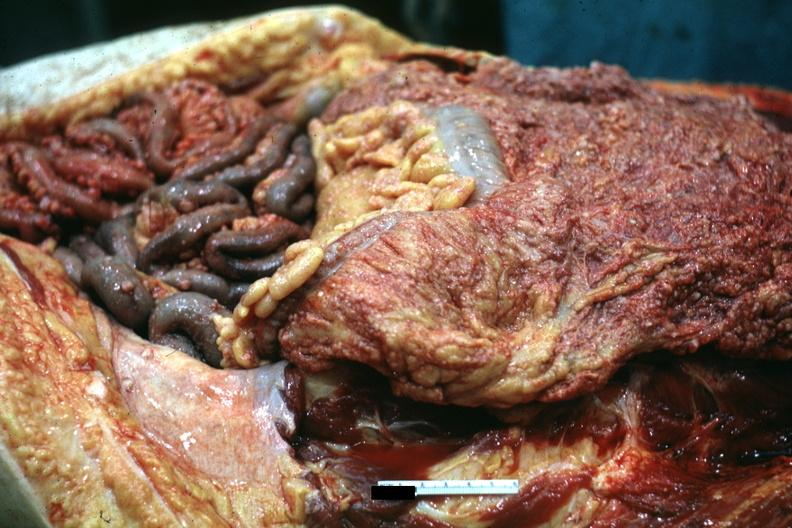does this image show opened abdominal cavity with extensive tumor implants on omentum and bowel?
Answer the question using a single word or phrase. Yes 